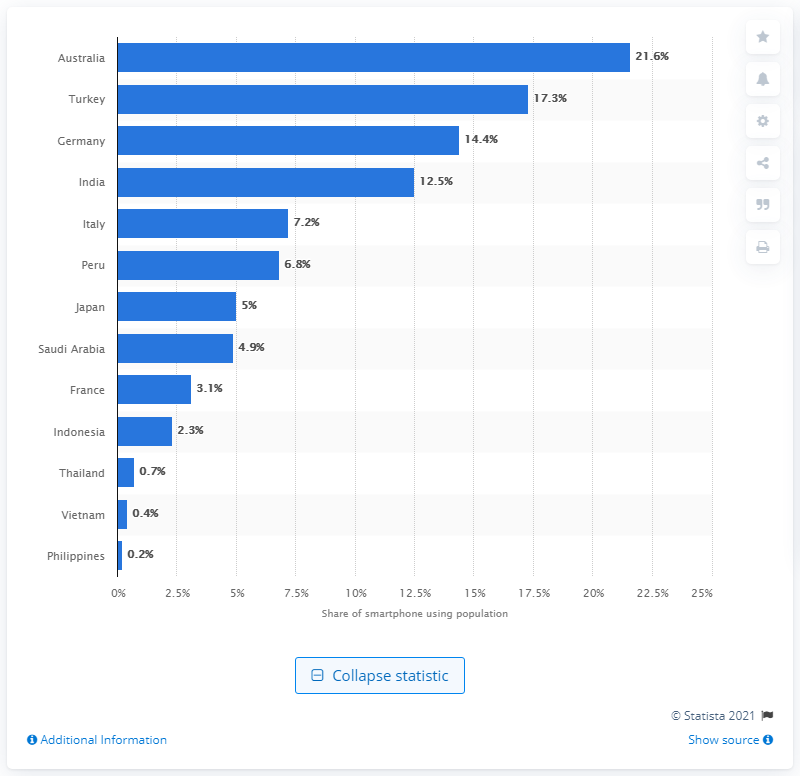Mention a couple of crucial points in this snapshot. Approximately 4% of Vietnam's population has adopted the use of COVID-19 apps. 